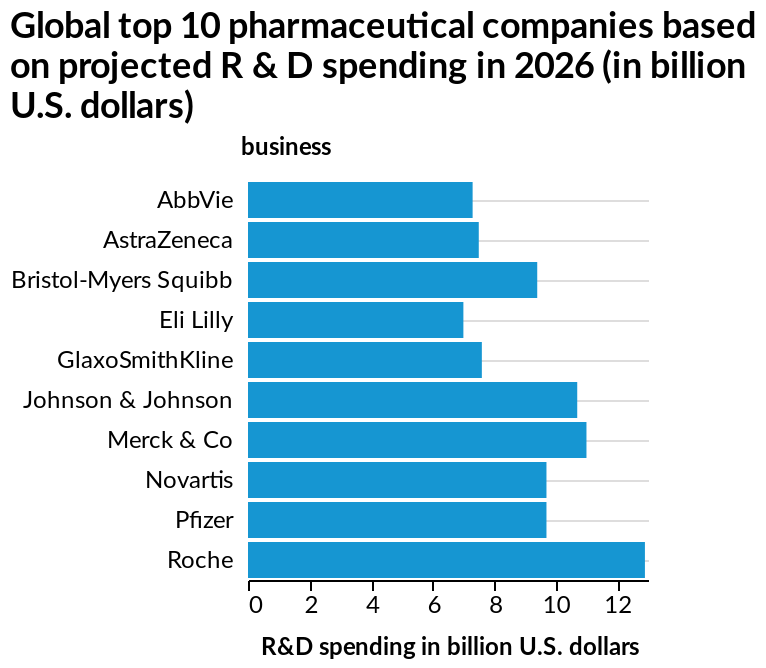<image>
Name the pharmaceutical company that is projected to spend the most in 2026. The information provided only states that Roche is projected to spend more than 12 billion US dollars in 2026, but it does not specify which pharmaceutical company is projected to spend the most. What is the name of the bar plot?  The bar plot is named "Global top 10 pharmaceutical companies based on projected R & D spending in 2026 (in billion U.S. dollars)." Which pharmaceutical company is projected to spend the least compared to the top 10?  Eli Lilly is the pharma projected to spend the least amount of money compared to all other top 10 pharmaceuticals. please enumerates aspects of the construction of the chart Here a bar plot is named Global top 10 pharmaceutical companies based on projected R & D spending in 2026 (in billion U.S. dollars). business is measured along the y-axis. A linear scale of range 0 to 12 can be found along the x-axis, labeled R&D spending in billion U.S. dollars. In what year is the R&D spending projected to be the highest? The description does not provide information about the year with the highest projected R&D spending. 